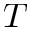Convert formula to latex. <formula><loc_0><loc_0><loc_500><loc_500>T</formula> 